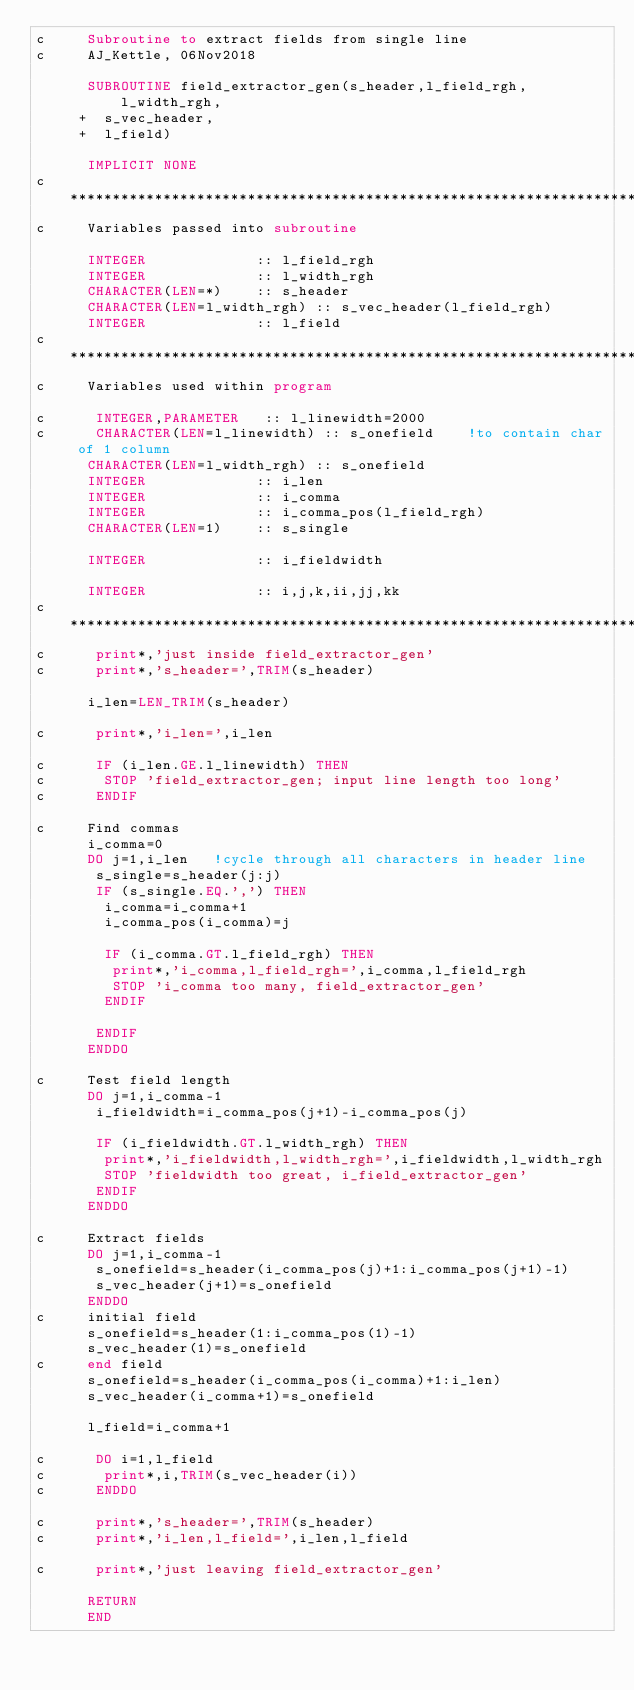Convert code to text. <code><loc_0><loc_0><loc_500><loc_500><_FORTRAN_>c     Subroutine to extract fields from single line
c     AJ_Kettle, 06Nov2018

      SUBROUTINE field_extractor_gen(s_header,l_field_rgh,l_width_rgh,
     +  s_vec_header,
     +  l_field) 

      IMPLICIT NONE
c************************************************************************
c     Variables passed into subroutine

      INTEGER             :: l_field_rgh
      INTEGER             :: l_width_rgh
      CHARACTER(LEN=*)    :: s_header
      CHARACTER(LEN=l_width_rgh) :: s_vec_header(l_field_rgh)
      INTEGER             :: l_field
c***********************************************************************
c     Variables used within program

c      INTEGER,PARAMETER   :: l_linewidth=2000
c      CHARACTER(LEN=l_linewidth) :: s_onefield    !to contain char of 1 column
      CHARACTER(LEN=l_width_rgh) :: s_onefield
      INTEGER             :: i_len
      INTEGER             :: i_comma
      INTEGER             :: i_comma_pos(l_field_rgh)
      CHARACTER(LEN=1)    :: s_single

      INTEGER             :: i_fieldwidth

      INTEGER             :: i,j,k,ii,jj,kk
c************************************************************************
c      print*,'just inside field_extractor_gen'
c      print*,'s_header=',TRIM(s_header)

      i_len=LEN_TRIM(s_header)

c      print*,'i_len=',i_len

c      IF (i_len.GE.l_linewidth) THEN 
c       STOP 'field_extractor_gen; input line length too long'
c      ENDIF

c     Find commas
      i_comma=0
      DO j=1,i_len   !cycle through all characters in header line
       s_single=s_header(j:j)
       IF (s_single.EQ.',') THEN
        i_comma=i_comma+1
        i_comma_pos(i_comma)=j

        IF (i_comma.GT.l_field_rgh) THEN
         print*,'i_comma,l_field_rgh=',i_comma,l_field_rgh
         STOP 'i_comma too many, field_extractor_gen'
        ENDIF

       ENDIF
      ENDDO

c     Test field length
      DO j=1,i_comma-1
       i_fieldwidth=i_comma_pos(j+1)-i_comma_pos(j)

       IF (i_fieldwidth.GT.l_width_rgh) THEN
        print*,'i_fieldwidth,l_width_rgh=',i_fieldwidth,l_width_rgh
        STOP 'fieldwidth too great, i_field_extractor_gen'
       ENDIF
      ENDDO

c     Extract fields
      DO j=1,i_comma-1
       s_onefield=s_header(i_comma_pos(j)+1:i_comma_pos(j+1)-1)
       s_vec_header(j+1)=s_onefield
      ENDDO
c     initial field
      s_onefield=s_header(1:i_comma_pos(1)-1)
      s_vec_header(1)=s_onefield
c     end field
      s_onefield=s_header(i_comma_pos(i_comma)+1:i_len)
      s_vec_header(i_comma+1)=s_onefield

      l_field=i_comma+1

c      DO i=1,l_field
c       print*,i,TRIM(s_vec_header(i))
c      ENDDO

c      print*,'s_header=',TRIM(s_header)
c      print*,'i_len,l_field=',i_len,l_field

c      print*,'just leaving field_extractor_gen'

      RETURN
      END
</code> 